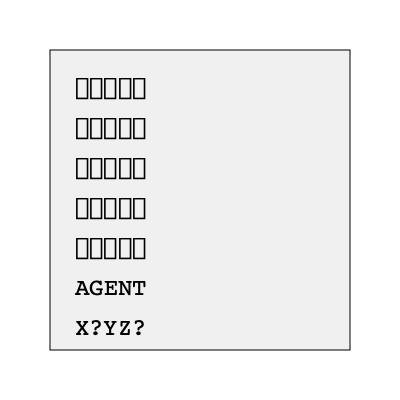Decode the cipher to reveal the hidden message. What are the missing letters in the final line? 1. Observe that the first five rows form a Latin square of symbols.
2. Each symbol corresponds to a letter in "AGENT":
   ★ = A, ◆ = G, ● = E, ■ = N, ▲ = T
3. The sixth row confirms this mapping.
4. Apply this mapping to the last row:
   X = unknown, ? = G, Y = E, Z = N, ? = T
5. The pattern suggests a rotation, so X should be A.
6. The last unknown symbol should complete the word, which is likely "AGENT".
7. Therefore, the missing letter is A.
Answer: A, A 